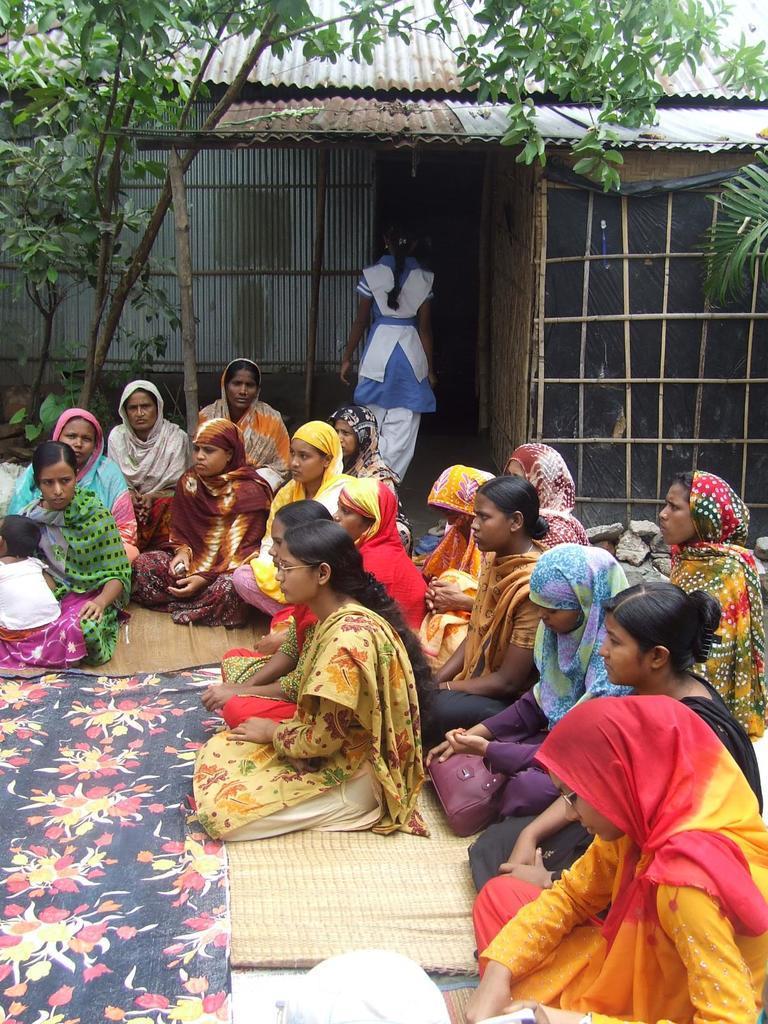In one or two sentences, can you explain what this image depicts? In this image there are group of women sitting on the mat. In the background there is a house. On the left side top corner there are trees. On the floor there is mat. At the top there are asbestos sheets over the house. 